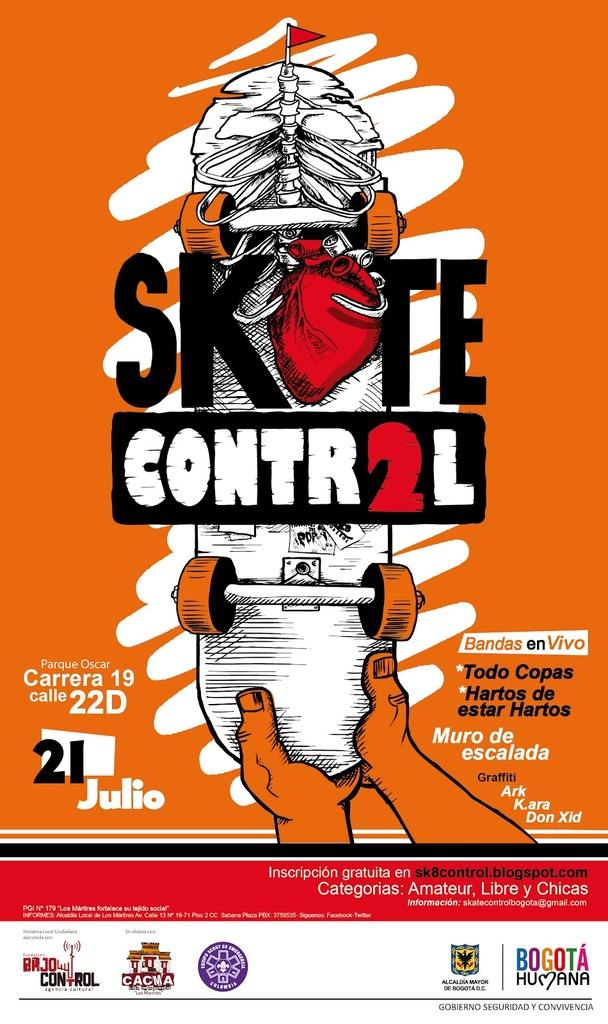<image>
Write a terse but informative summary of the picture. a picture of a magazine or book cover that shows the words skate control 